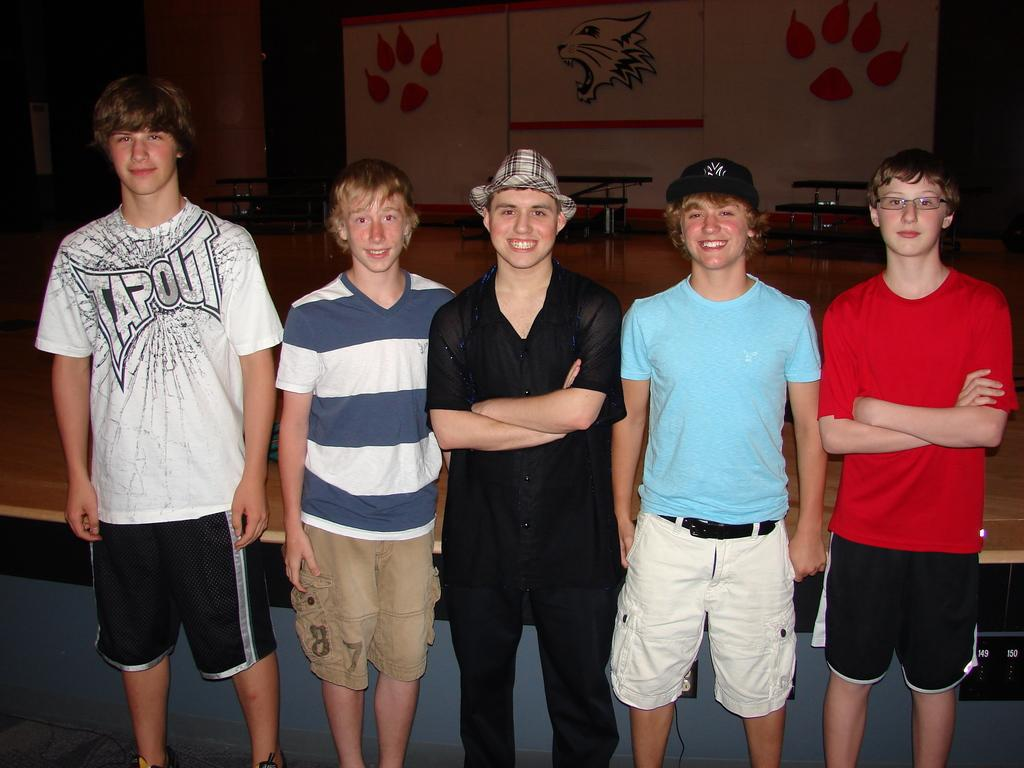What is happening in the image? There are people standing in the image. Can you describe the background of the image? There are objects visible in the background of the image. What is the rate at which the shoe is rolling in the image? There is no shoe present in the image, and therefore no rolling shoe to measure the rate of. 